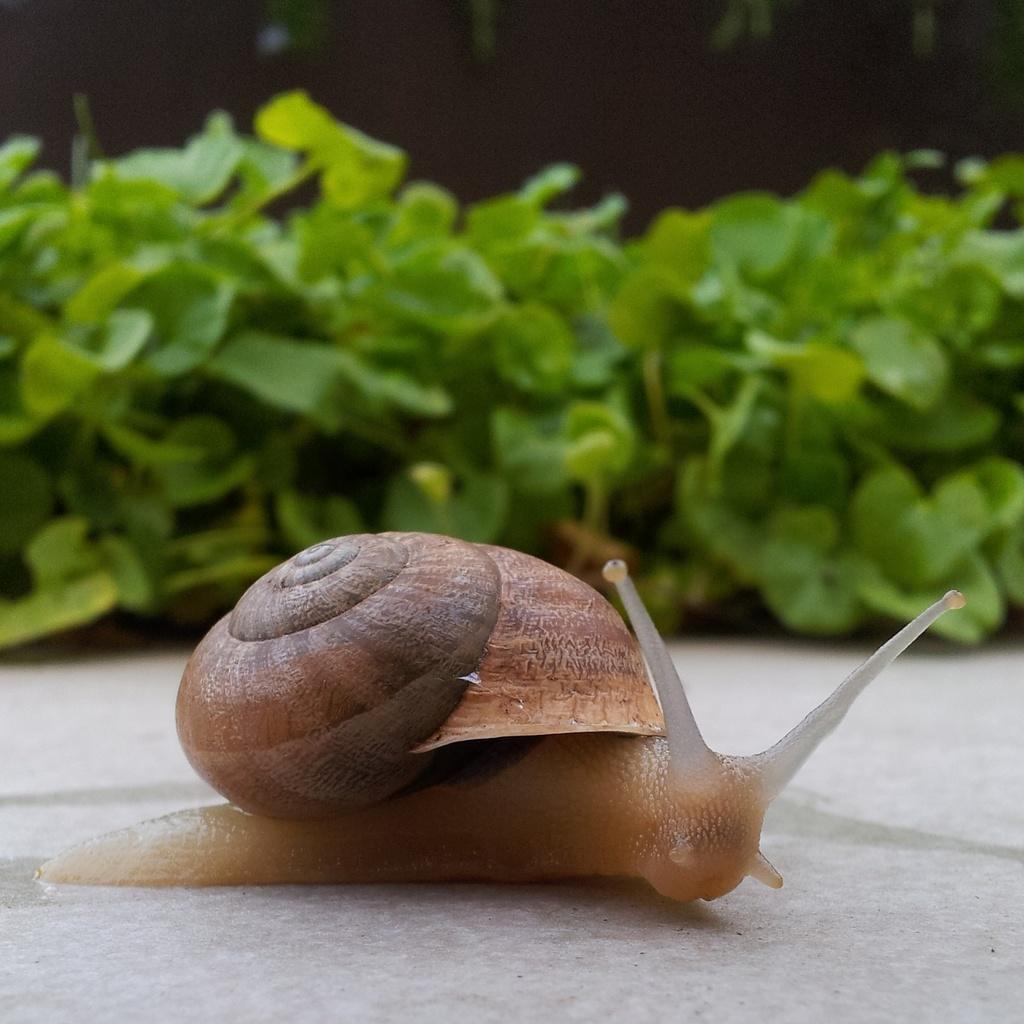Describe this image in one or two sentences. In the center of the image there is a snail. In the background there are plants. 